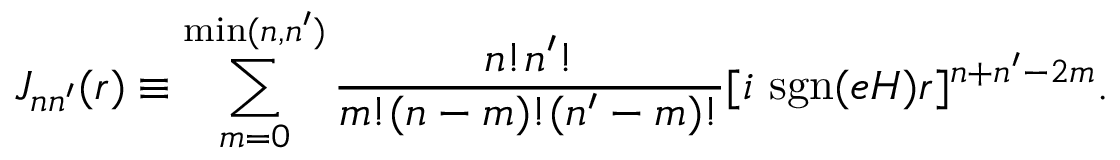<formula> <loc_0><loc_0><loc_500><loc_500>J _ { n n ^ { \prime } } ( r ) \equiv \sum _ { m = 0 } ^ { \min ( n , n ^ { \prime } ) } \frac { n ! n ^ { \prime } ! } { m ! ( n - m ) ! ( n ^ { \prime } - m ) ! } [ i s g n ( e H ) r ] ^ { n + n ^ { \prime } - 2 m } .</formula> 